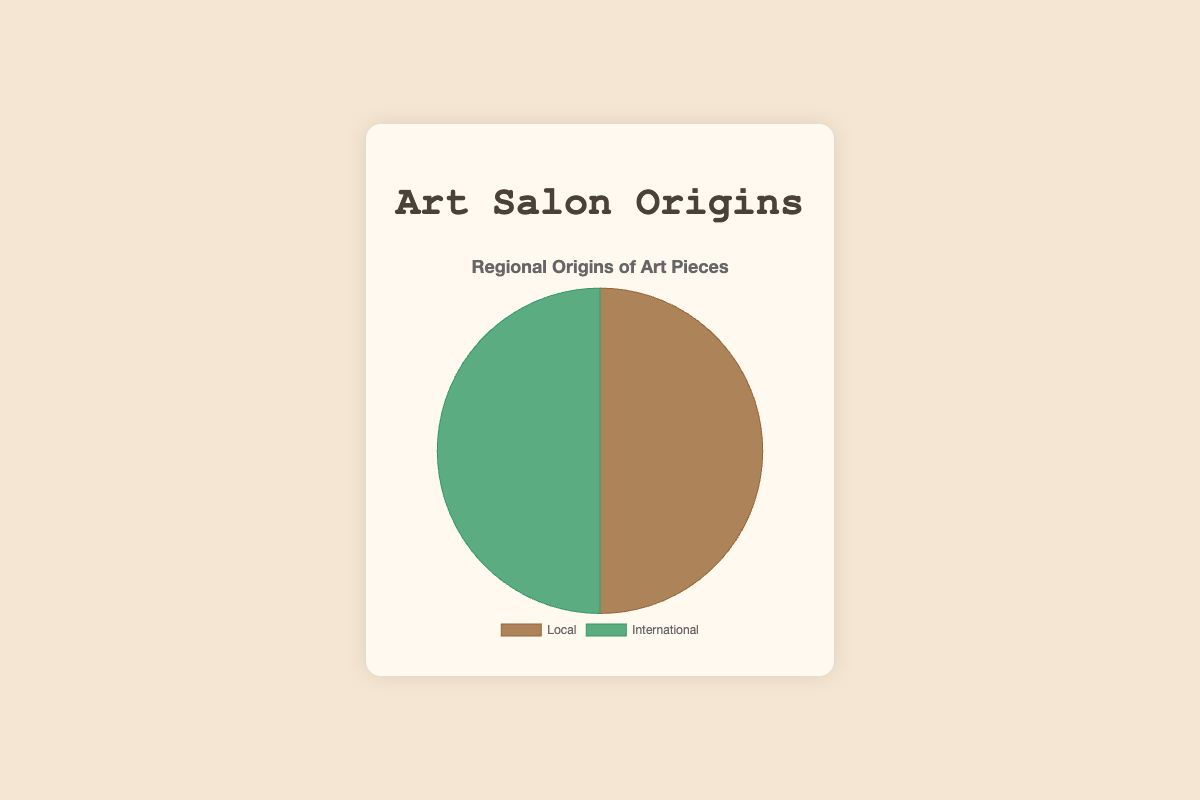How many local art pieces are there? We count the number of slices labeled “Local” in the pie chart.
Answer: 4 What is the percentage of international art pieces compared to the total? The total number of art pieces is 8 (4 local + 4 international). The number of international pieces is 4. So, the percentage is calculated as (4/8) * 100 = 50%.
Answer: 50% Which type of art piece, local or international, is more represented, and by how much? Both local and international art pieces are equally represented. There are 4 local and 4 international pieces.
Answer: Equal What is the ratio of local to international art pieces? We count the number of local and international pieces respectively. Both are 4, so the ratio is 1:1.
Answer: 1:1 What mathematical operations could be performed to check if there is an equal representation of local and international art pieces? Check if the count of local (4) minus the count of international (4) equals zero, i.e., 4 - 4 = 0.
Answer: Subtracting the counts equal zero How does the visual representation help in quickly understanding the distribution of local vs. international art pieces? The pie chart uses different colors for local and international, making it easy to see that they both occupy equal proportions of the chart.
Answer: Visual clarity If one more local art piece is added, how will it affect the chart? Adding one more local piece will change the total count to 9 (5 local + 4 international). The pie slice for local will slightly increase, and its percentage will be (5/9) * 100 ≈ 55.56%.
Answer: Local percentage increases to 55.56% Describe the color representation for local and international art pieces in the chart. "Local" pieces are represented by a brownish color, while "International" pieces are depicted in green.
Answer: Brown for Local, Green for International How many more international art pieces would need to be added to make them a larger proportion than local? Currently, both are equal at 4 pieces each. Adding one more international piece (total 5) would make international pieces outnumber local.
Answer: 1 What logical operation can you perform to verify the pie chart data is accurate? Sum the local and international pieces to check if they sum to the total number: 4 (local) + 4 (international) = 8 (total).
Answer: Sum verification 